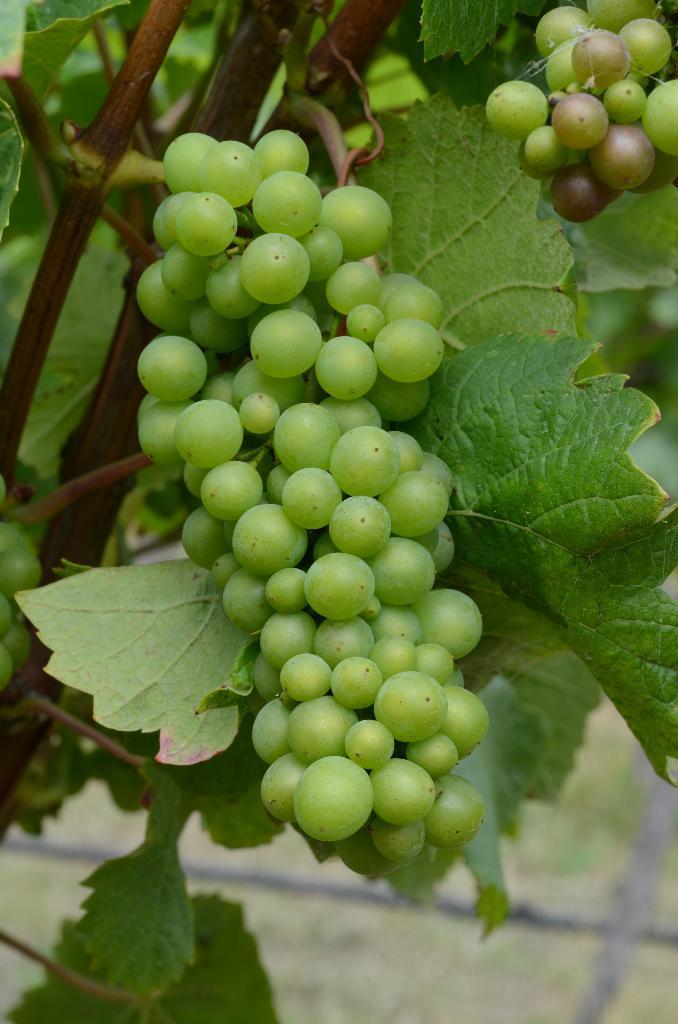In one or two sentences, can you explain what this image depicts? In this image we can see bunch of grapes and leaves. 